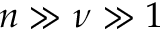<formula> <loc_0><loc_0><loc_500><loc_500>n \gg \nu \gg 1</formula> 